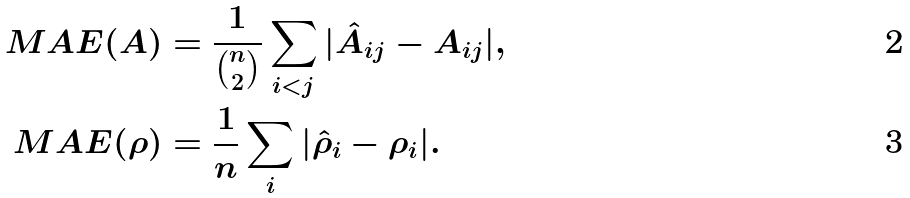<formula> <loc_0><loc_0><loc_500><loc_500>M A E ( A ) & = \frac { 1 } { \binom { n } { 2 } } \sum _ { i < j } | \hat { A } _ { i j } - A _ { i j } | , \\ M A E ( \rho ) & = \frac { 1 } { n } \sum _ { i } | \hat { \rho } _ { i } - \rho _ { i } | .</formula> 